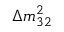<formula> <loc_0><loc_0><loc_500><loc_500>\Delta m _ { 3 2 } ^ { 2 }</formula> 